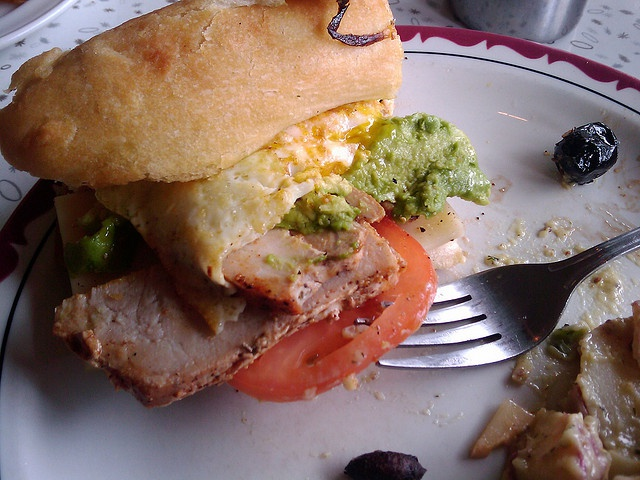Describe the objects in this image and their specific colors. I can see sandwich in maroon, black, and tan tones, fork in maroon, black, lavender, gray, and darkgray tones, and broccoli in maroon, olive, and tan tones in this image. 